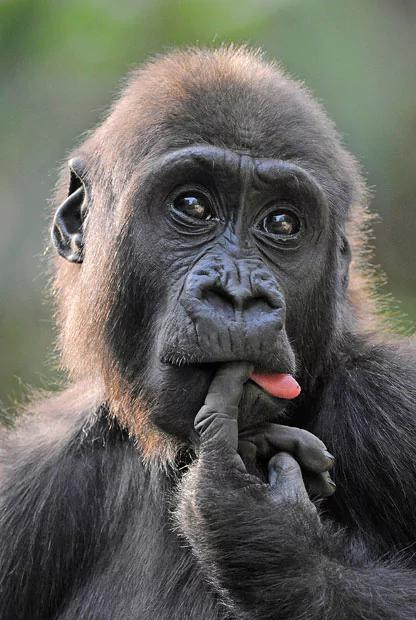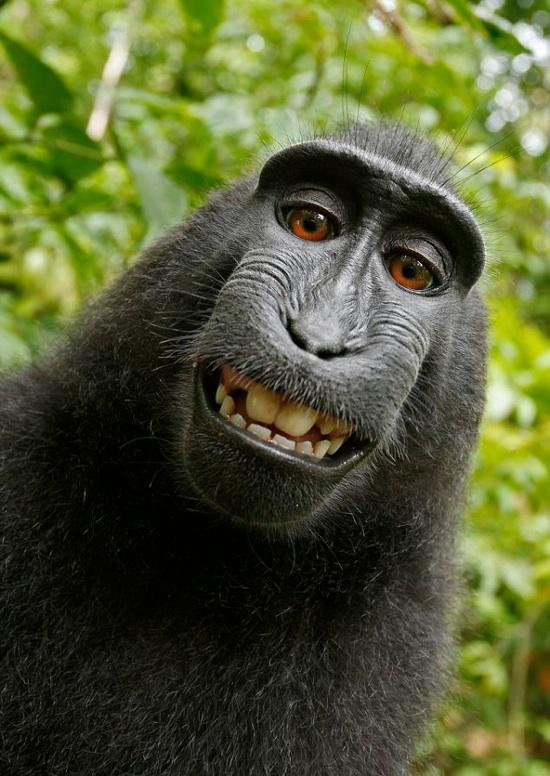The first image is the image on the left, the second image is the image on the right. Evaluate the accuracy of this statement regarding the images: "At least one primate is sticking their tongue out.". Is it true? Answer yes or no. Yes. The first image is the image on the left, the second image is the image on the right. Analyze the images presented: Is the assertion "A small monkey with non-black fur scratches its head, in one image." valid? Answer yes or no. No. 